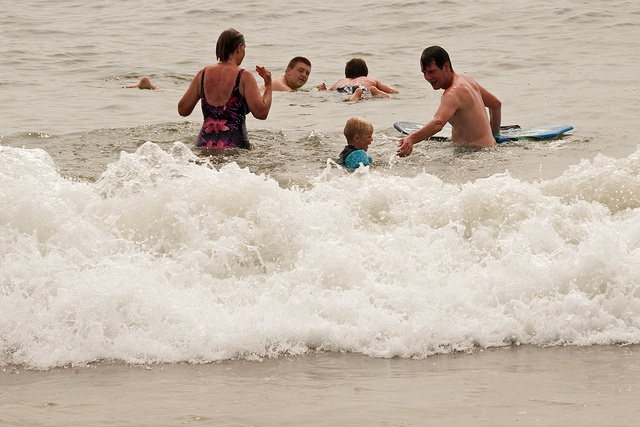Describe the objects in this image and their specific colors. I can see people in darkgray, black, maroon, and brown tones, people in darkgray, maroon, brown, and black tones, people in darkgray, black, tan, and salmon tones, people in darkgray, maroon, black, and teal tones, and people in darkgray, brown, maroon, and black tones in this image. 